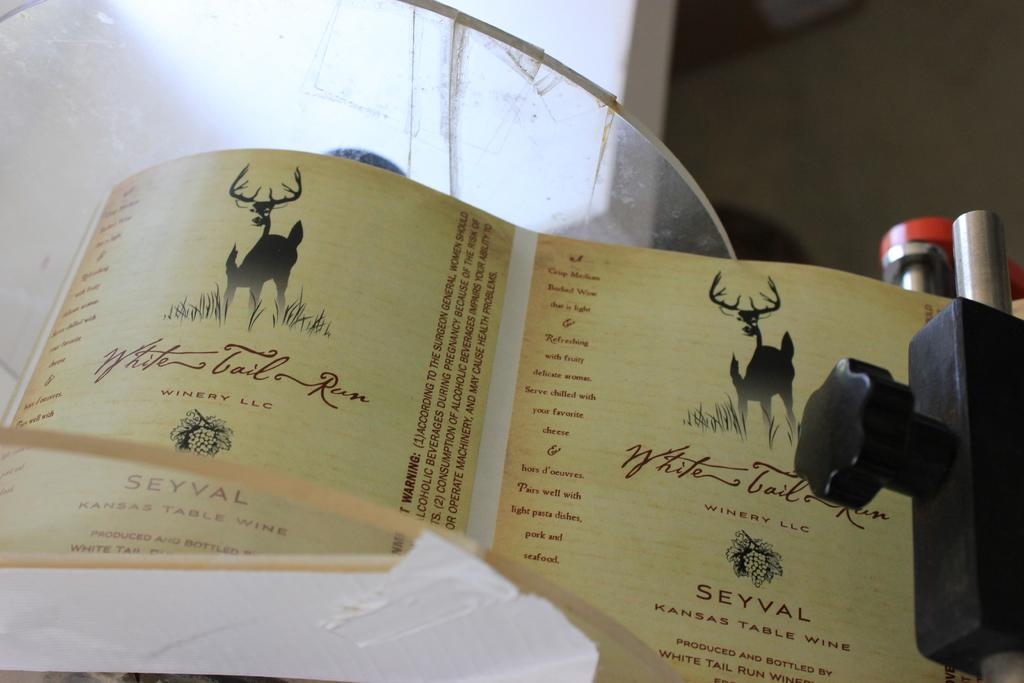<image>
Create a compact narrative representing the image presented. A label featuring a deer and bearing the words Kansas Table Wine. 